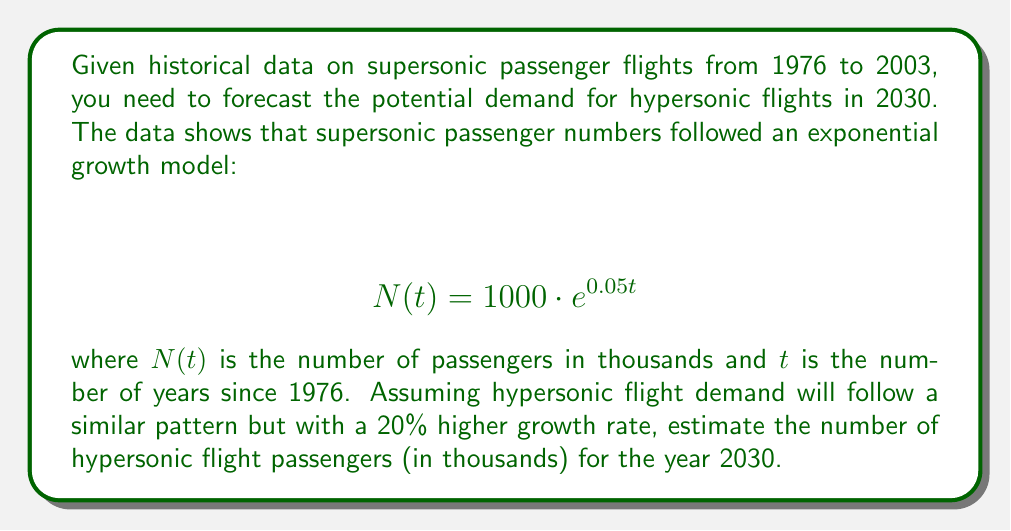Provide a solution to this math problem. To solve this problem, we'll follow these steps:

1) First, we need to adjust the growth rate for hypersonic flights. The original growth rate for supersonic flights was 0.05, and hypersonic flights are expected to have a 20% higher growth rate. So, the new growth rate is:

   $0.05 \cdot 1.20 = 0.06$

2) Now, we need to modify our exponential growth model for hypersonic flights:

   $$ N(t) = 1000 \cdot e^{0.06t} $$

3) We need to calculate $t$ for the year 2030. Since our base year is 1976:

   $t = 2030 - 1976 = 54$

4) Now we can plug this into our equation:

   $$ N(54) = 1000 \cdot e^{0.06 \cdot 54} $$

5) Let's calculate this step by step:
   
   $$ N(54) = 1000 \cdot e^{3.24} $$
   $$ N(54) = 1000 \cdot 25.53 $$
   $$ N(54) = 25,530 $$

Therefore, the estimated number of hypersonic flight passengers in 2030 would be approximately 25,530 thousand, or 25.53 million.
Answer: 25,530 thousand passengers (or 25.53 million passengers) 